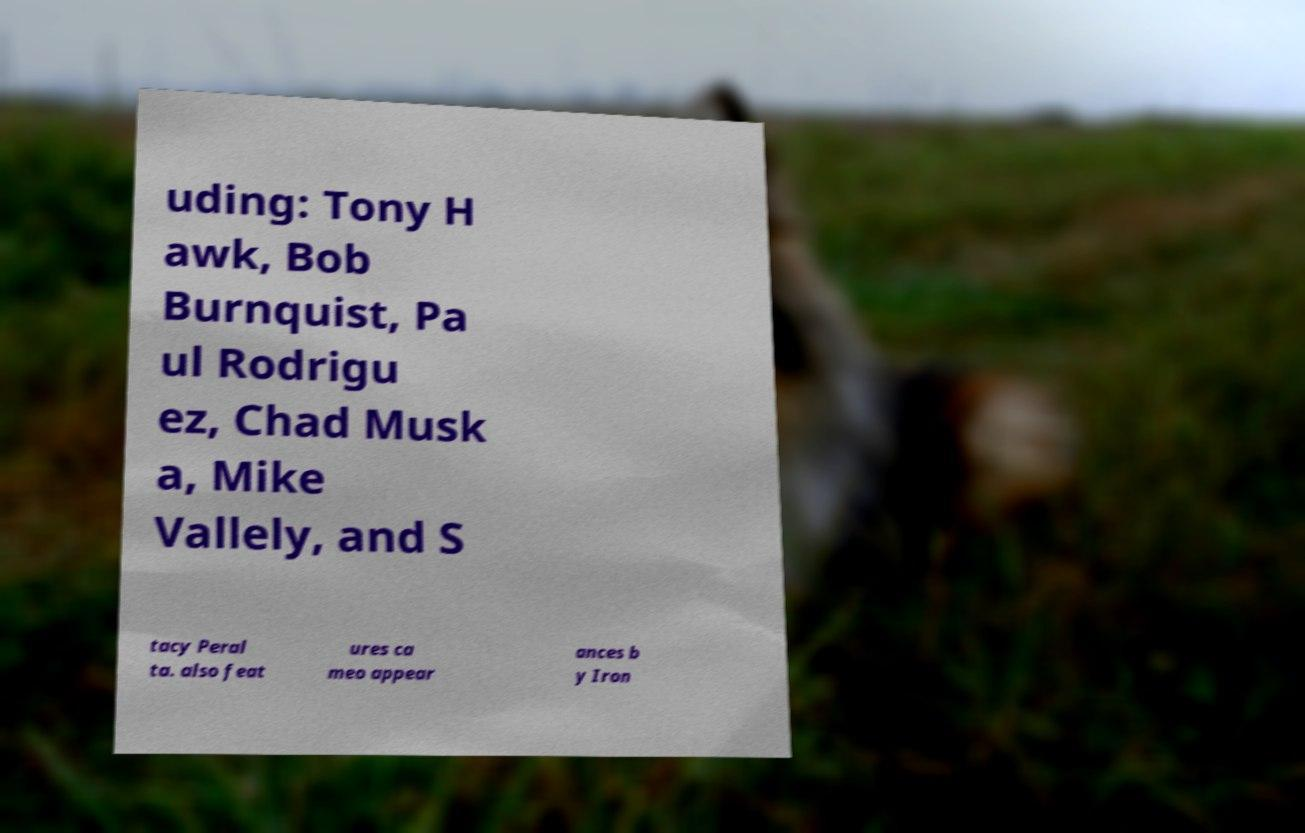Please read and relay the text visible in this image. What does it say? uding: Tony H awk, Bob Burnquist, Pa ul Rodrigu ez, Chad Musk a, Mike Vallely, and S tacy Peral ta. also feat ures ca meo appear ances b y Iron 